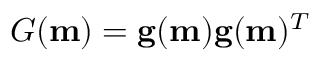<formula> <loc_0><loc_0><loc_500><loc_500>G ( m ) = g ( m ) g ( m ) ^ { T }</formula> 